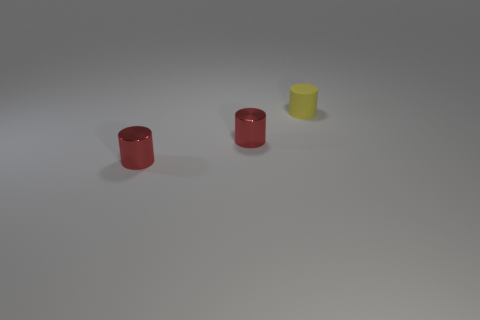Can you guess what material these objects might be made of? While it's impossible to be certain without additional context or information, the objects could likely be made of plastic or a similar synthetic material, given their smooth textures and vibrant colors. 